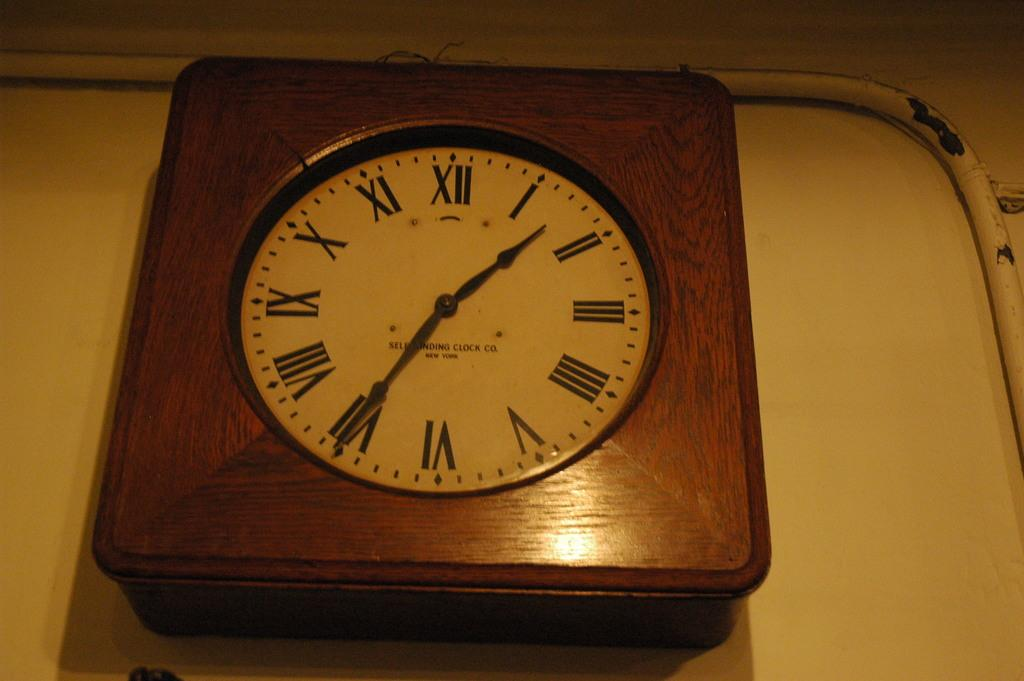<image>
Write a terse but informative summary of the picture. An old analog clock with roman numerals reads Self Winding Clock Co. New York. 